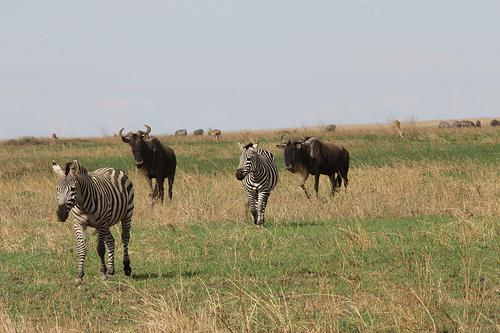Question: where was the picture taken?
Choices:
A. In the zoo.
B. At home.
C. In a field.
D. On the street.
Answer with the letter. Answer: C Question: what color are the zebras?
Choices:
A. Black and white.
B. Gray and black.
C. Yellow and tan.
D. Orange and brown.
Answer with the letter. Answer: A Question: where are the zebras?
Choices:
A. In the fence.
B. In the cage.
C. In the zoo.
D. On the grass.
Answer with the letter. Answer: D Question: what is under the zebras?
Choices:
A. Concrete.
B. Dirt.
C. Grass.
D. Rocks.
Answer with the letter. Answer: C 